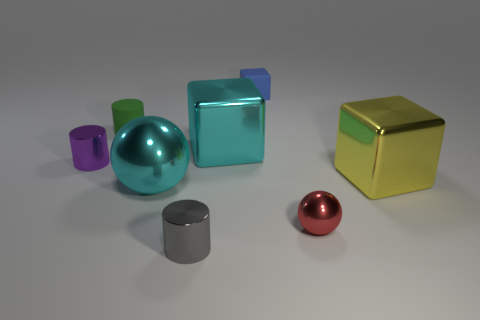Subtract all big shiny blocks. How many blocks are left? 1 Add 1 small red balls. How many objects exist? 9 Subtract all cyan balls. How many balls are left? 1 Subtract 3 cylinders. How many cylinders are left? 0 Subtract all red blocks. How many cyan spheres are left? 1 Add 1 cyan things. How many cyan things are left? 3 Add 2 large cyan shiny blocks. How many large cyan shiny blocks exist? 3 Subtract 0 gray blocks. How many objects are left? 8 Subtract all blocks. How many objects are left? 5 Subtract all cyan cubes. Subtract all gray cylinders. How many cubes are left? 2 